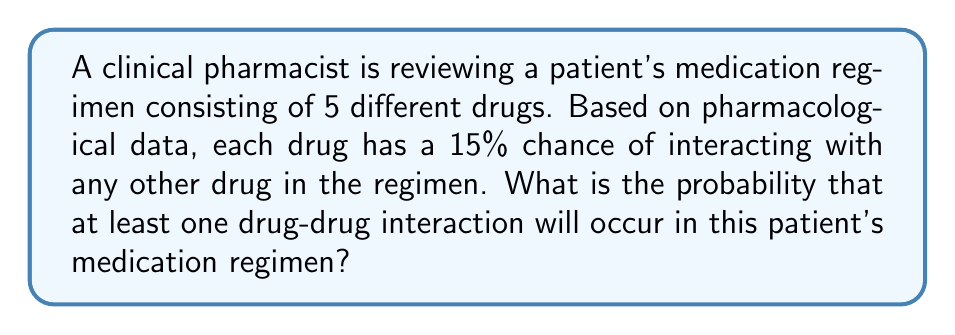Can you answer this question? To solve this problem, we'll use the complementary probability approach:

1) First, let's calculate the probability of no interactions occurring.

2) For each pair of drugs, the probability of no interaction is 85% (1 - 0.15 = 0.85).

3) With 5 drugs, there are $\binom{5}{2} = 10$ possible pairs of drugs.

4) The probability of no interactions at all is the probability that none of these 10 pairs interact:

   $P(\text{no interactions}) = 0.85^{10} \approx 0.1969$

5) Therefore, the probability of at least one interaction is the complement of this:

   $P(\text{at least one interaction}) = 1 - P(\text{no interactions})$
   $= 1 - 0.85^{10}$
   $\approx 1 - 0.1969$
   $\approx 0.8031$

So, the probability of at least one drug-drug interaction occurring is approximately 0.8031 or 80.31%.
Answer: The probability of at least one drug-drug interaction occurring is approximately 0.8031 or 80.31%. 